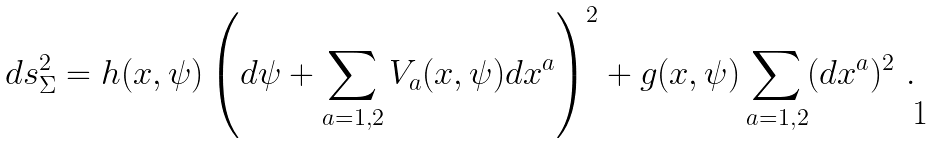Convert formula to latex. <formula><loc_0><loc_0><loc_500><loc_500>d s _ { \Sigma } ^ { 2 } = h ( x , \psi ) \left ( d \psi + \sum _ { a = 1 , 2 } V _ { a } ( x , \psi ) d x ^ { a } \right ) ^ { 2 } + g ( x , \psi ) \sum _ { a = 1 , 2 } ( d x ^ { a } ) ^ { 2 } \ .</formula> 